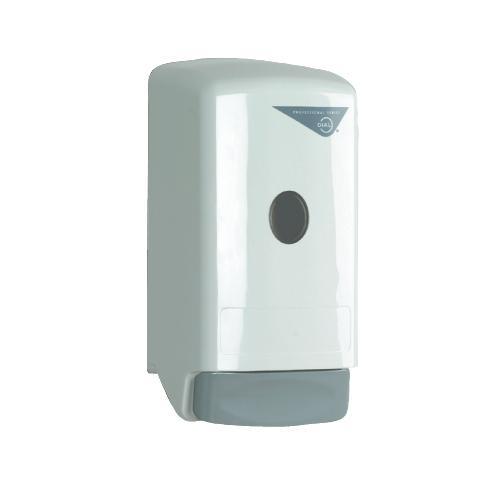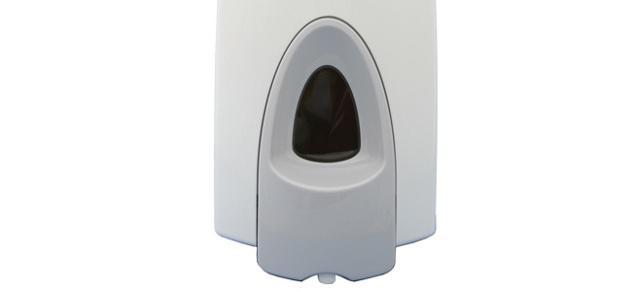The first image is the image on the left, the second image is the image on the right. For the images displayed, is the sentence "The soap dispenser in the right image has a rectangular inlay." factually correct? Answer yes or no. No. The first image is the image on the left, the second image is the image on the right. Given the left and right images, does the statement "the dispenser button in the image on the left is light gray" hold true? Answer yes or no. Yes. 